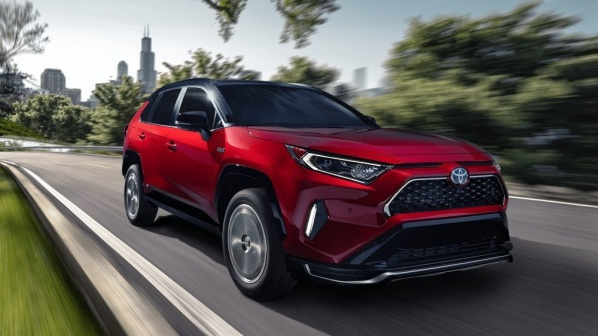Imagine this car is in a futuristic city. Can you describe the scene? In a futuristic city, this red Toyota RAV4 glides smoothly along a road lined with sleek, towering skyscrapers made of reflective glass and filled with greenery. Holographic billboards and signs illuminate the streets with vibrant advertisements. Drones zip overhead, and autonomous vehicles move seamlessly through the organized traffic. The skies are clear, and the environment is clean and high-tech. The car, now equipped with fully autonomous driving capabilities, effortlessly navigates through the city using advanced sensors and AI, interacting with other connected systems to provide the smoothest, most efficient ride. 